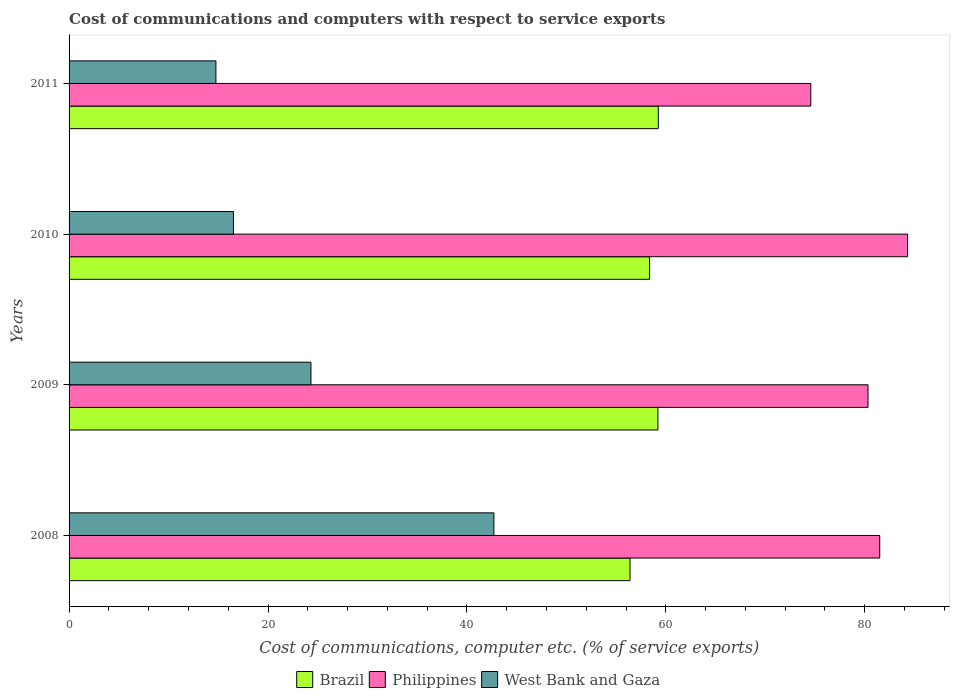How many different coloured bars are there?
Your answer should be compact. 3. How many groups of bars are there?
Give a very brief answer. 4. Are the number of bars per tick equal to the number of legend labels?
Your response must be concise. Yes. In how many cases, is the number of bars for a given year not equal to the number of legend labels?
Ensure brevity in your answer.  0. What is the cost of communications and computers in West Bank and Gaza in 2010?
Your response must be concise. 16.52. Across all years, what is the maximum cost of communications and computers in West Bank and Gaza?
Give a very brief answer. 42.71. Across all years, what is the minimum cost of communications and computers in Brazil?
Your answer should be very brief. 56.4. What is the total cost of communications and computers in Philippines in the graph?
Offer a terse response. 320.71. What is the difference between the cost of communications and computers in Brazil in 2008 and that in 2011?
Provide a short and direct response. -2.84. What is the difference between the cost of communications and computers in Brazil in 2009 and the cost of communications and computers in Philippines in 2011?
Give a very brief answer. -15.37. What is the average cost of communications and computers in West Bank and Gaza per year?
Offer a terse response. 24.58. In the year 2010, what is the difference between the cost of communications and computers in Philippines and cost of communications and computers in Brazil?
Provide a succinct answer. 25.94. In how many years, is the cost of communications and computers in Brazil greater than 12 %?
Ensure brevity in your answer.  4. What is the ratio of the cost of communications and computers in Philippines in 2009 to that in 2011?
Provide a succinct answer. 1.08. Is the cost of communications and computers in Brazil in 2008 less than that in 2011?
Offer a very short reply. Yes. What is the difference between the highest and the second highest cost of communications and computers in Philippines?
Offer a very short reply. 2.8. What is the difference between the highest and the lowest cost of communications and computers in West Bank and Gaza?
Your response must be concise. 27.95. In how many years, is the cost of communications and computers in West Bank and Gaza greater than the average cost of communications and computers in West Bank and Gaza taken over all years?
Offer a very short reply. 1. What does the 2nd bar from the top in 2008 represents?
Make the answer very short. Philippines. What does the 3rd bar from the bottom in 2010 represents?
Keep it short and to the point. West Bank and Gaza. What is the difference between two consecutive major ticks on the X-axis?
Offer a very short reply. 20. Does the graph contain any zero values?
Your answer should be very brief. No. Does the graph contain grids?
Give a very brief answer. No. How many legend labels are there?
Provide a short and direct response. 3. What is the title of the graph?
Your answer should be very brief. Cost of communications and computers with respect to service exports. What is the label or title of the X-axis?
Keep it short and to the point. Cost of communications, computer etc. (% of service exports). What is the label or title of the Y-axis?
Offer a very short reply. Years. What is the Cost of communications, computer etc. (% of service exports) in Brazil in 2008?
Offer a terse response. 56.4. What is the Cost of communications, computer etc. (% of service exports) in Philippines in 2008?
Your answer should be compact. 81.51. What is the Cost of communications, computer etc. (% of service exports) in West Bank and Gaza in 2008?
Provide a short and direct response. 42.71. What is the Cost of communications, computer etc. (% of service exports) in Brazil in 2009?
Your response must be concise. 59.2. What is the Cost of communications, computer etc. (% of service exports) in Philippines in 2009?
Provide a short and direct response. 80.33. What is the Cost of communications, computer etc. (% of service exports) in West Bank and Gaza in 2009?
Make the answer very short. 24.32. What is the Cost of communications, computer etc. (% of service exports) in Brazil in 2010?
Ensure brevity in your answer.  58.37. What is the Cost of communications, computer etc. (% of service exports) of Philippines in 2010?
Ensure brevity in your answer.  84.3. What is the Cost of communications, computer etc. (% of service exports) in West Bank and Gaza in 2010?
Your answer should be compact. 16.52. What is the Cost of communications, computer etc. (% of service exports) of Brazil in 2011?
Provide a succinct answer. 59.24. What is the Cost of communications, computer etc. (% of service exports) in Philippines in 2011?
Your answer should be very brief. 74.57. What is the Cost of communications, computer etc. (% of service exports) in West Bank and Gaza in 2011?
Keep it short and to the point. 14.76. Across all years, what is the maximum Cost of communications, computer etc. (% of service exports) in Brazil?
Provide a short and direct response. 59.24. Across all years, what is the maximum Cost of communications, computer etc. (% of service exports) of Philippines?
Keep it short and to the point. 84.3. Across all years, what is the maximum Cost of communications, computer etc. (% of service exports) in West Bank and Gaza?
Your response must be concise. 42.71. Across all years, what is the minimum Cost of communications, computer etc. (% of service exports) of Brazil?
Provide a succinct answer. 56.4. Across all years, what is the minimum Cost of communications, computer etc. (% of service exports) in Philippines?
Offer a terse response. 74.57. Across all years, what is the minimum Cost of communications, computer etc. (% of service exports) of West Bank and Gaza?
Keep it short and to the point. 14.76. What is the total Cost of communications, computer etc. (% of service exports) of Brazil in the graph?
Make the answer very short. 233.22. What is the total Cost of communications, computer etc. (% of service exports) in Philippines in the graph?
Your response must be concise. 320.71. What is the total Cost of communications, computer etc. (% of service exports) in West Bank and Gaza in the graph?
Ensure brevity in your answer.  98.32. What is the difference between the Cost of communications, computer etc. (% of service exports) in Brazil in 2008 and that in 2009?
Provide a succinct answer. -2.8. What is the difference between the Cost of communications, computer etc. (% of service exports) of Philippines in 2008 and that in 2009?
Offer a very short reply. 1.18. What is the difference between the Cost of communications, computer etc. (% of service exports) of West Bank and Gaza in 2008 and that in 2009?
Your response must be concise. 18.39. What is the difference between the Cost of communications, computer etc. (% of service exports) in Brazil in 2008 and that in 2010?
Give a very brief answer. -1.97. What is the difference between the Cost of communications, computer etc. (% of service exports) in Philippines in 2008 and that in 2010?
Offer a terse response. -2.8. What is the difference between the Cost of communications, computer etc. (% of service exports) of West Bank and Gaza in 2008 and that in 2010?
Offer a terse response. 26.19. What is the difference between the Cost of communications, computer etc. (% of service exports) of Brazil in 2008 and that in 2011?
Your answer should be compact. -2.84. What is the difference between the Cost of communications, computer etc. (% of service exports) of Philippines in 2008 and that in 2011?
Give a very brief answer. 6.93. What is the difference between the Cost of communications, computer etc. (% of service exports) of West Bank and Gaza in 2008 and that in 2011?
Offer a terse response. 27.95. What is the difference between the Cost of communications, computer etc. (% of service exports) in Brazil in 2009 and that in 2010?
Provide a succinct answer. 0.84. What is the difference between the Cost of communications, computer etc. (% of service exports) of Philippines in 2009 and that in 2010?
Ensure brevity in your answer.  -3.98. What is the difference between the Cost of communications, computer etc. (% of service exports) in West Bank and Gaza in 2009 and that in 2010?
Your answer should be compact. 7.79. What is the difference between the Cost of communications, computer etc. (% of service exports) in Brazil in 2009 and that in 2011?
Provide a short and direct response. -0.04. What is the difference between the Cost of communications, computer etc. (% of service exports) of Philippines in 2009 and that in 2011?
Keep it short and to the point. 5.75. What is the difference between the Cost of communications, computer etc. (% of service exports) in West Bank and Gaza in 2009 and that in 2011?
Make the answer very short. 9.55. What is the difference between the Cost of communications, computer etc. (% of service exports) of Brazil in 2010 and that in 2011?
Your response must be concise. -0.87. What is the difference between the Cost of communications, computer etc. (% of service exports) in Philippines in 2010 and that in 2011?
Give a very brief answer. 9.73. What is the difference between the Cost of communications, computer etc. (% of service exports) of West Bank and Gaza in 2010 and that in 2011?
Your answer should be compact. 1.76. What is the difference between the Cost of communications, computer etc. (% of service exports) in Brazil in 2008 and the Cost of communications, computer etc. (% of service exports) in Philippines in 2009?
Give a very brief answer. -23.93. What is the difference between the Cost of communications, computer etc. (% of service exports) of Brazil in 2008 and the Cost of communications, computer etc. (% of service exports) of West Bank and Gaza in 2009?
Offer a terse response. 32.08. What is the difference between the Cost of communications, computer etc. (% of service exports) of Philippines in 2008 and the Cost of communications, computer etc. (% of service exports) of West Bank and Gaza in 2009?
Make the answer very short. 57.19. What is the difference between the Cost of communications, computer etc. (% of service exports) of Brazil in 2008 and the Cost of communications, computer etc. (% of service exports) of Philippines in 2010?
Your answer should be very brief. -27.9. What is the difference between the Cost of communications, computer etc. (% of service exports) of Brazil in 2008 and the Cost of communications, computer etc. (% of service exports) of West Bank and Gaza in 2010?
Ensure brevity in your answer.  39.88. What is the difference between the Cost of communications, computer etc. (% of service exports) of Philippines in 2008 and the Cost of communications, computer etc. (% of service exports) of West Bank and Gaza in 2010?
Give a very brief answer. 64.98. What is the difference between the Cost of communications, computer etc. (% of service exports) in Brazil in 2008 and the Cost of communications, computer etc. (% of service exports) in Philippines in 2011?
Ensure brevity in your answer.  -18.17. What is the difference between the Cost of communications, computer etc. (% of service exports) of Brazil in 2008 and the Cost of communications, computer etc. (% of service exports) of West Bank and Gaza in 2011?
Your response must be concise. 41.64. What is the difference between the Cost of communications, computer etc. (% of service exports) of Philippines in 2008 and the Cost of communications, computer etc. (% of service exports) of West Bank and Gaza in 2011?
Make the answer very short. 66.74. What is the difference between the Cost of communications, computer etc. (% of service exports) in Brazil in 2009 and the Cost of communications, computer etc. (% of service exports) in Philippines in 2010?
Make the answer very short. -25.1. What is the difference between the Cost of communications, computer etc. (% of service exports) in Brazil in 2009 and the Cost of communications, computer etc. (% of service exports) in West Bank and Gaza in 2010?
Make the answer very short. 42.68. What is the difference between the Cost of communications, computer etc. (% of service exports) of Philippines in 2009 and the Cost of communications, computer etc. (% of service exports) of West Bank and Gaza in 2010?
Keep it short and to the point. 63.8. What is the difference between the Cost of communications, computer etc. (% of service exports) in Brazil in 2009 and the Cost of communications, computer etc. (% of service exports) in Philippines in 2011?
Make the answer very short. -15.37. What is the difference between the Cost of communications, computer etc. (% of service exports) in Brazil in 2009 and the Cost of communications, computer etc. (% of service exports) in West Bank and Gaza in 2011?
Make the answer very short. 44.44. What is the difference between the Cost of communications, computer etc. (% of service exports) in Philippines in 2009 and the Cost of communications, computer etc. (% of service exports) in West Bank and Gaza in 2011?
Provide a succinct answer. 65.56. What is the difference between the Cost of communications, computer etc. (% of service exports) of Brazil in 2010 and the Cost of communications, computer etc. (% of service exports) of Philippines in 2011?
Offer a very short reply. -16.21. What is the difference between the Cost of communications, computer etc. (% of service exports) in Brazil in 2010 and the Cost of communications, computer etc. (% of service exports) in West Bank and Gaza in 2011?
Provide a short and direct response. 43.6. What is the difference between the Cost of communications, computer etc. (% of service exports) of Philippines in 2010 and the Cost of communications, computer etc. (% of service exports) of West Bank and Gaza in 2011?
Your answer should be very brief. 69.54. What is the average Cost of communications, computer etc. (% of service exports) of Brazil per year?
Your response must be concise. 58.3. What is the average Cost of communications, computer etc. (% of service exports) of Philippines per year?
Offer a terse response. 80.18. What is the average Cost of communications, computer etc. (% of service exports) in West Bank and Gaza per year?
Offer a very short reply. 24.58. In the year 2008, what is the difference between the Cost of communications, computer etc. (% of service exports) of Brazil and Cost of communications, computer etc. (% of service exports) of Philippines?
Provide a short and direct response. -25.1. In the year 2008, what is the difference between the Cost of communications, computer etc. (% of service exports) of Brazil and Cost of communications, computer etc. (% of service exports) of West Bank and Gaza?
Offer a terse response. 13.69. In the year 2008, what is the difference between the Cost of communications, computer etc. (% of service exports) in Philippines and Cost of communications, computer etc. (% of service exports) in West Bank and Gaza?
Offer a terse response. 38.79. In the year 2009, what is the difference between the Cost of communications, computer etc. (% of service exports) of Brazil and Cost of communications, computer etc. (% of service exports) of Philippines?
Offer a very short reply. -21.12. In the year 2009, what is the difference between the Cost of communications, computer etc. (% of service exports) of Brazil and Cost of communications, computer etc. (% of service exports) of West Bank and Gaza?
Keep it short and to the point. 34.89. In the year 2009, what is the difference between the Cost of communications, computer etc. (% of service exports) of Philippines and Cost of communications, computer etc. (% of service exports) of West Bank and Gaza?
Your answer should be very brief. 56.01. In the year 2010, what is the difference between the Cost of communications, computer etc. (% of service exports) in Brazil and Cost of communications, computer etc. (% of service exports) in Philippines?
Provide a short and direct response. -25.94. In the year 2010, what is the difference between the Cost of communications, computer etc. (% of service exports) in Brazil and Cost of communications, computer etc. (% of service exports) in West Bank and Gaza?
Your answer should be very brief. 41.84. In the year 2010, what is the difference between the Cost of communications, computer etc. (% of service exports) of Philippines and Cost of communications, computer etc. (% of service exports) of West Bank and Gaza?
Provide a succinct answer. 67.78. In the year 2011, what is the difference between the Cost of communications, computer etc. (% of service exports) in Brazil and Cost of communications, computer etc. (% of service exports) in Philippines?
Give a very brief answer. -15.33. In the year 2011, what is the difference between the Cost of communications, computer etc. (% of service exports) in Brazil and Cost of communications, computer etc. (% of service exports) in West Bank and Gaza?
Your response must be concise. 44.48. In the year 2011, what is the difference between the Cost of communications, computer etc. (% of service exports) in Philippines and Cost of communications, computer etc. (% of service exports) in West Bank and Gaza?
Your answer should be compact. 59.81. What is the ratio of the Cost of communications, computer etc. (% of service exports) of Brazil in 2008 to that in 2009?
Your answer should be very brief. 0.95. What is the ratio of the Cost of communications, computer etc. (% of service exports) in Philippines in 2008 to that in 2009?
Your answer should be compact. 1.01. What is the ratio of the Cost of communications, computer etc. (% of service exports) of West Bank and Gaza in 2008 to that in 2009?
Offer a terse response. 1.76. What is the ratio of the Cost of communications, computer etc. (% of service exports) in Brazil in 2008 to that in 2010?
Your response must be concise. 0.97. What is the ratio of the Cost of communications, computer etc. (% of service exports) of Philippines in 2008 to that in 2010?
Offer a terse response. 0.97. What is the ratio of the Cost of communications, computer etc. (% of service exports) in West Bank and Gaza in 2008 to that in 2010?
Your answer should be very brief. 2.58. What is the ratio of the Cost of communications, computer etc. (% of service exports) in Brazil in 2008 to that in 2011?
Make the answer very short. 0.95. What is the ratio of the Cost of communications, computer etc. (% of service exports) of Philippines in 2008 to that in 2011?
Offer a terse response. 1.09. What is the ratio of the Cost of communications, computer etc. (% of service exports) of West Bank and Gaza in 2008 to that in 2011?
Make the answer very short. 2.89. What is the ratio of the Cost of communications, computer etc. (% of service exports) of Brazil in 2009 to that in 2010?
Offer a very short reply. 1.01. What is the ratio of the Cost of communications, computer etc. (% of service exports) in Philippines in 2009 to that in 2010?
Offer a terse response. 0.95. What is the ratio of the Cost of communications, computer etc. (% of service exports) in West Bank and Gaza in 2009 to that in 2010?
Make the answer very short. 1.47. What is the ratio of the Cost of communications, computer etc. (% of service exports) in Philippines in 2009 to that in 2011?
Offer a terse response. 1.08. What is the ratio of the Cost of communications, computer etc. (% of service exports) in West Bank and Gaza in 2009 to that in 2011?
Offer a terse response. 1.65. What is the ratio of the Cost of communications, computer etc. (% of service exports) in Brazil in 2010 to that in 2011?
Provide a succinct answer. 0.99. What is the ratio of the Cost of communications, computer etc. (% of service exports) in Philippines in 2010 to that in 2011?
Ensure brevity in your answer.  1.13. What is the ratio of the Cost of communications, computer etc. (% of service exports) in West Bank and Gaza in 2010 to that in 2011?
Give a very brief answer. 1.12. What is the difference between the highest and the second highest Cost of communications, computer etc. (% of service exports) in Brazil?
Keep it short and to the point. 0.04. What is the difference between the highest and the second highest Cost of communications, computer etc. (% of service exports) of Philippines?
Keep it short and to the point. 2.8. What is the difference between the highest and the second highest Cost of communications, computer etc. (% of service exports) of West Bank and Gaza?
Offer a very short reply. 18.39. What is the difference between the highest and the lowest Cost of communications, computer etc. (% of service exports) of Brazil?
Your answer should be compact. 2.84. What is the difference between the highest and the lowest Cost of communications, computer etc. (% of service exports) of Philippines?
Ensure brevity in your answer.  9.73. What is the difference between the highest and the lowest Cost of communications, computer etc. (% of service exports) in West Bank and Gaza?
Your answer should be very brief. 27.95. 